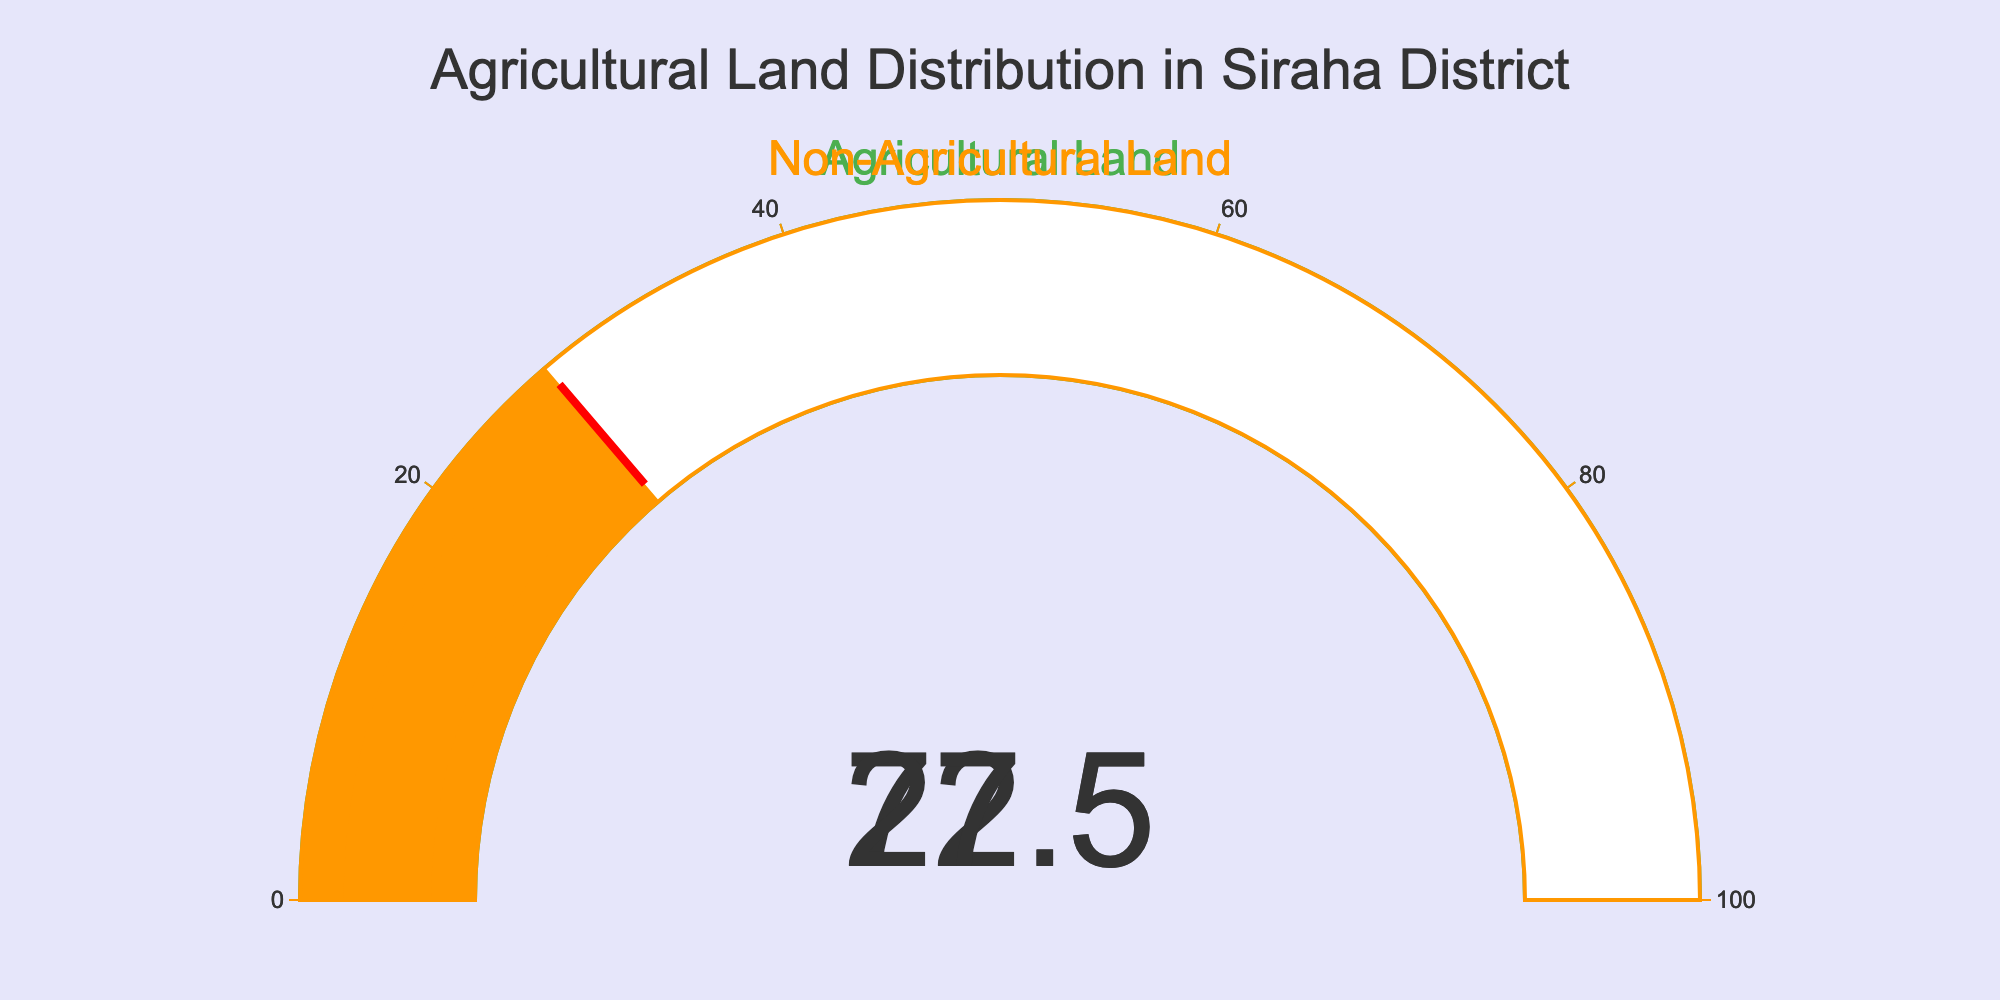What is the percentage of agricultural land in Siraha district? The gauge chart for Agricultural Land shows a value. The value displayed is 72.5%, indicating the percentage of agricultural land.
Answer: 72.5% What is the percentage of non-agricultural land in Siraha district? The gauge chart for Non-Agricultural Land shows a value. The displayed value is 27.5%, indicating the percentage of non-agricultural land.
Answer: 27.5% What is the title of the chart? The title is presented at the top of the figure and reads "Agricultural Land Distribution in Siraha District".
Answer: Agricultural Land Distribution in Siraha District What color is used to represent agricultural land? The color used for the Agricultural Land gauge is green, as observed in the gauge's bar color and steps.
Answer: Green What is the combined total percentage of agricultural and non-agricultural land in Siraha? The percentage of agricultural land is 72.5%, and non-agricultural land is 27.5%. Adding these two gives us 72.5 + 27.5 = 100%.
Answer: 100% Which category occupies more land in Siraha, agricultural or non-agricultural? By comparing the values on both gauges, the agricultural land shows 72.5% whereas non-agricultural land shows 27.5%. Agricultural land occupies more space.
Answer: Agricultural land What is the difference in percentage between agricultural and non-agricultural land? The percentage of agricultural land is 72.5%, and non-agricultural land is 27.5%. The difference is calculated as 72.5 - 27.5 = 45%.
Answer: 45% How many categories of land use are displayed in the chart? By inspecting the chart, we can see two distinct gauges: one for Agricultural Land and another for Non-Agricultural Land.
Answer: 2 Is the percentage of agricultural land above or below 50%? The gauge for agricultural land shows a value of 72.5%. Since 72.5% is greater than 50%, the percentage is above 50%.
Answer: Above 50% 